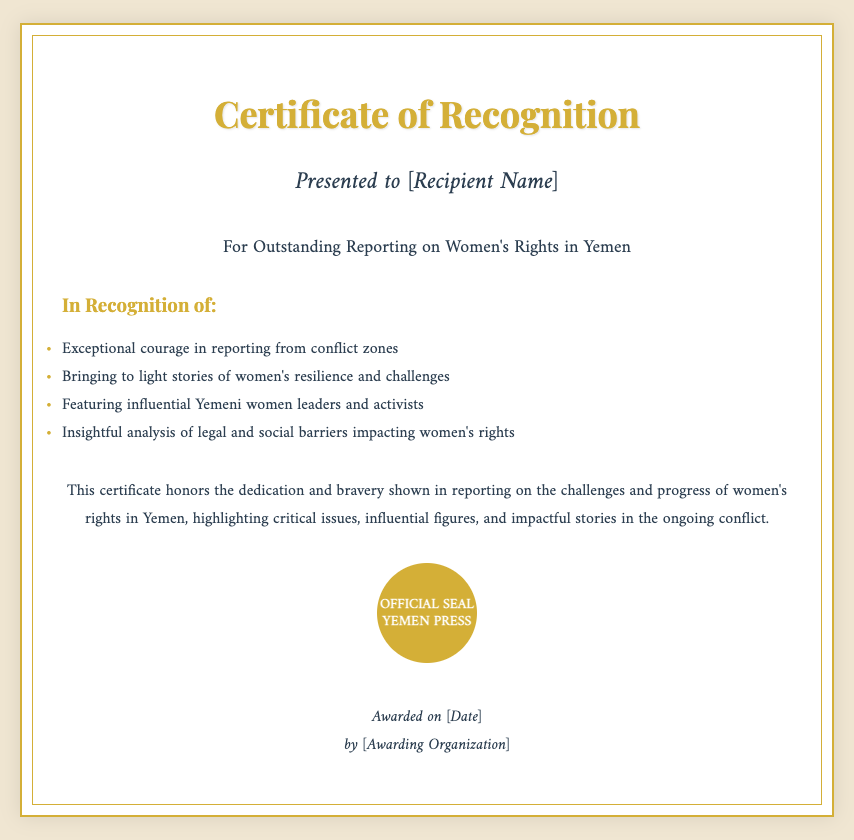What is the title of the certificate? The title is prominently displayed at the top of the certificate, which is "Certificate of Recognition."
Answer: Certificate of Recognition Who is the certificate presented to? The recipient's name is specified in the certificate, indicated as "[Recipient Name]."
Answer: [Recipient Name] What is the main focus of the reporting acknowledged by this certificate? The description below the title indicates the main subject of the reporting recognized by this certificate, which is women's rights in Yemen.
Answer: Women's Rights in Yemen What type of award is this? The document indicates that this is a certificate, as stated in the title and throughout the content.
Answer: Certificate What organization awarded this certificate? The awarding organization is indicated as "[Awarding Organization]."
Answer: [Awarding Organization] On what date was the certificate awarded? The date is specified in the document as "[Date]."
Answer: [Date] What color is the official seal? The seal is described in the document as having a background color of "#d4af37."
Answer: #d4af37 What is one of the reasons for the recognition mentioned in the highlights? The highlights section lists several reasons, such as "Exceptional courage in reporting from conflict zones."
Answer: Exceptional courage in reporting from conflict zones How does the certificate describe the individual's reporting on challenges? The certificate states that it honors "the dedication and bravery shown in reporting on the challenges and progress of women's rights in Yemen."
Answer: challenges and progress of women's rights in Yemen 